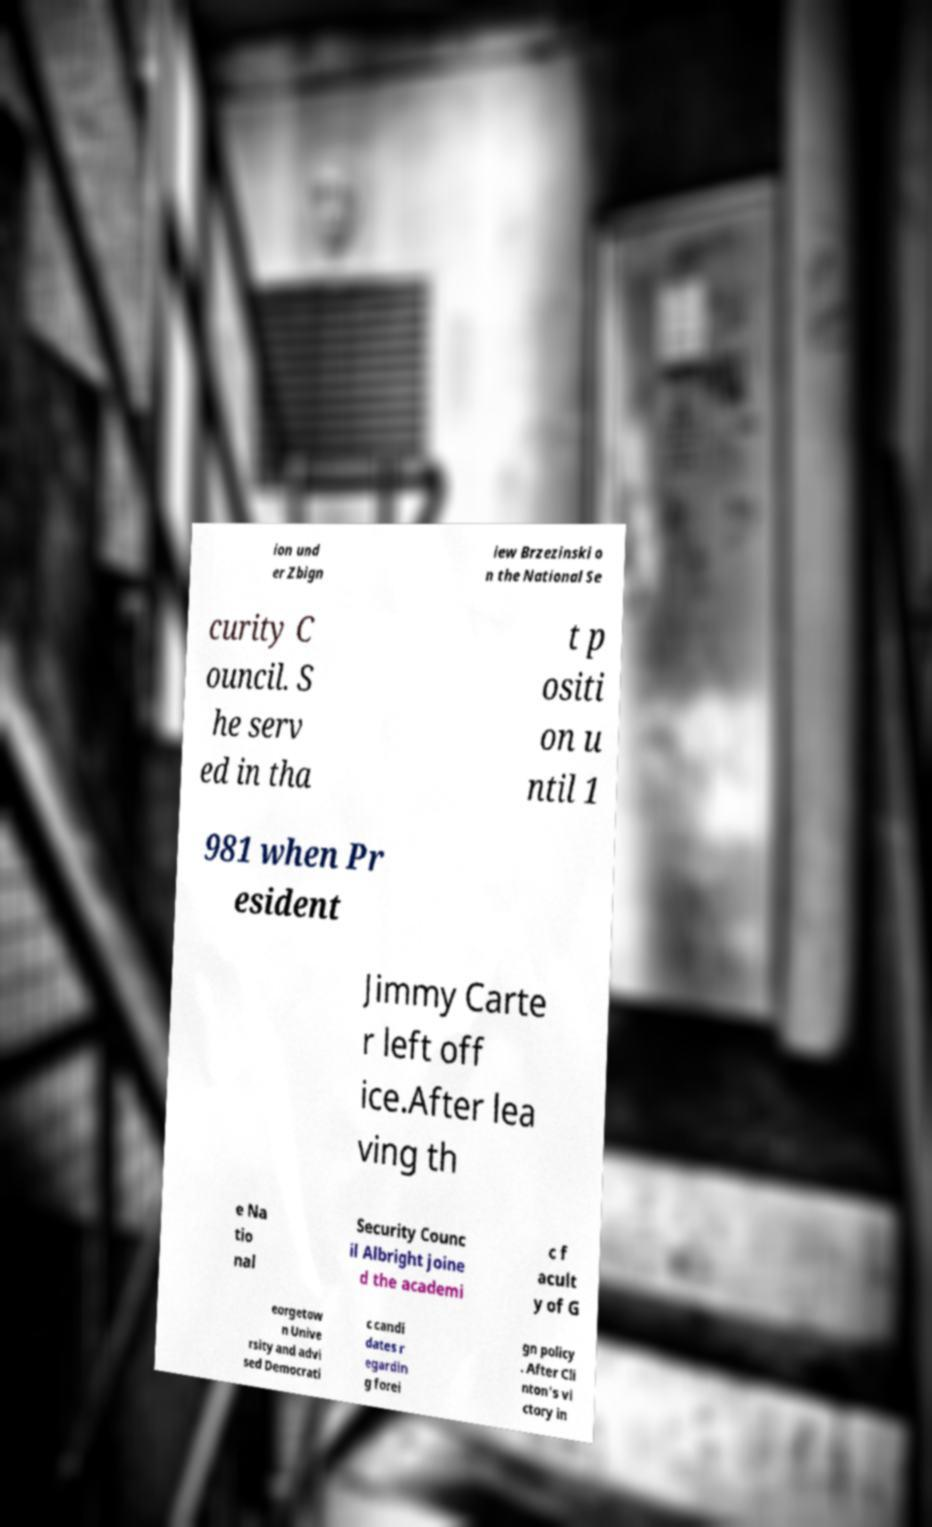There's text embedded in this image that I need extracted. Can you transcribe it verbatim? ion und er Zbign iew Brzezinski o n the National Se curity C ouncil. S he serv ed in tha t p ositi on u ntil 1 981 when Pr esident Jimmy Carte r left off ice.After lea ving th e Na tio nal Security Counc il Albright joine d the academi c f acult y of G eorgetow n Unive rsity and advi sed Democrati c candi dates r egardin g forei gn policy . After Cli nton's vi ctory in 